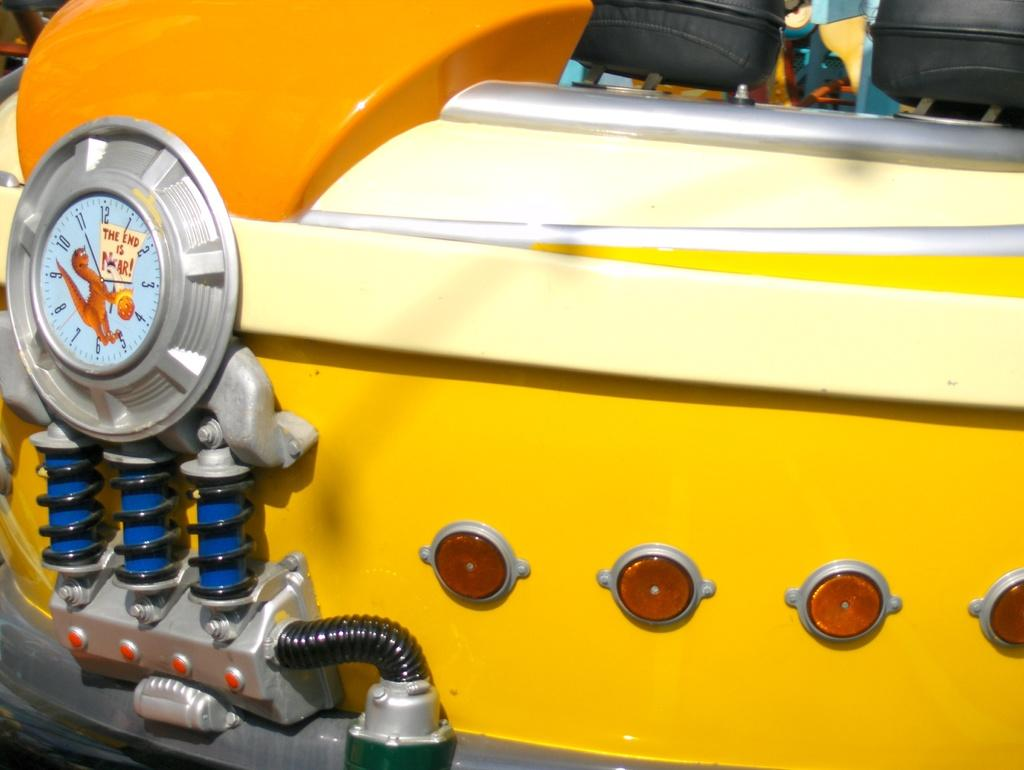What is the color of the machine in the image? The machine in the image is yellow. What feature can be seen on the left side of the machine? The machine has a meter on the left side. How many suspensions are attached to the machine? Three suspensions are attached to the machine. What is connected to the machine in the image? There is a wire associated with the machine. What shape can be observed on the machine? There are four round things on the machine. How many beds are visible in the image? There are no beds present in the image; it features a yellow machine with various features. 